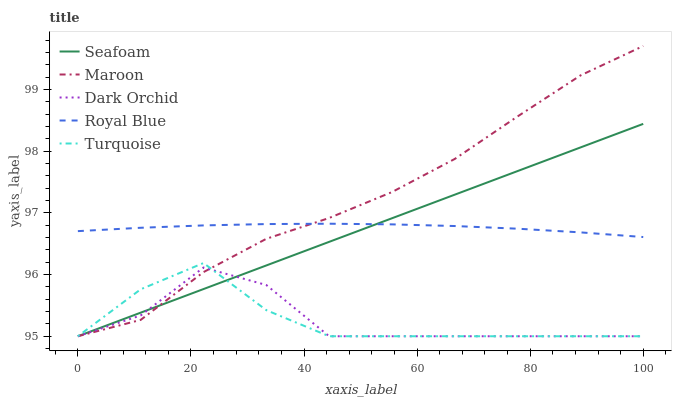Does Dark Orchid have the minimum area under the curve?
Answer yes or no. Yes. Does Maroon have the maximum area under the curve?
Answer yes or no. Yes. Does Royal Blue have the minimum area under the curve?
Answer yes or no. No. Does Royal Blue have the maximum area under the curve?
Answer yes or no. No. Is Seafoam the smoothest?
Answer yes or no. Yes. Is Dark Orchid the roughest?
Answer yes or no. Yes. Is Royal Blue the smoothest?
Answer yes or no. No. Is Royal Blue the roughest?
Answer yes or no. No. Does Royal Blue have the lowest value?
Answer yes or no. No. Does Royal Blue have the highest value?
Answer yes or no. No. Is Dark Orchid less than Royal Blue?
Answer yes or no. Yes. Is Royal Blue greater than Turquoise?
Answer yes or no. Yes. Does Dark Orchid intersect Royal Blue?
Answer yes or no. No. 